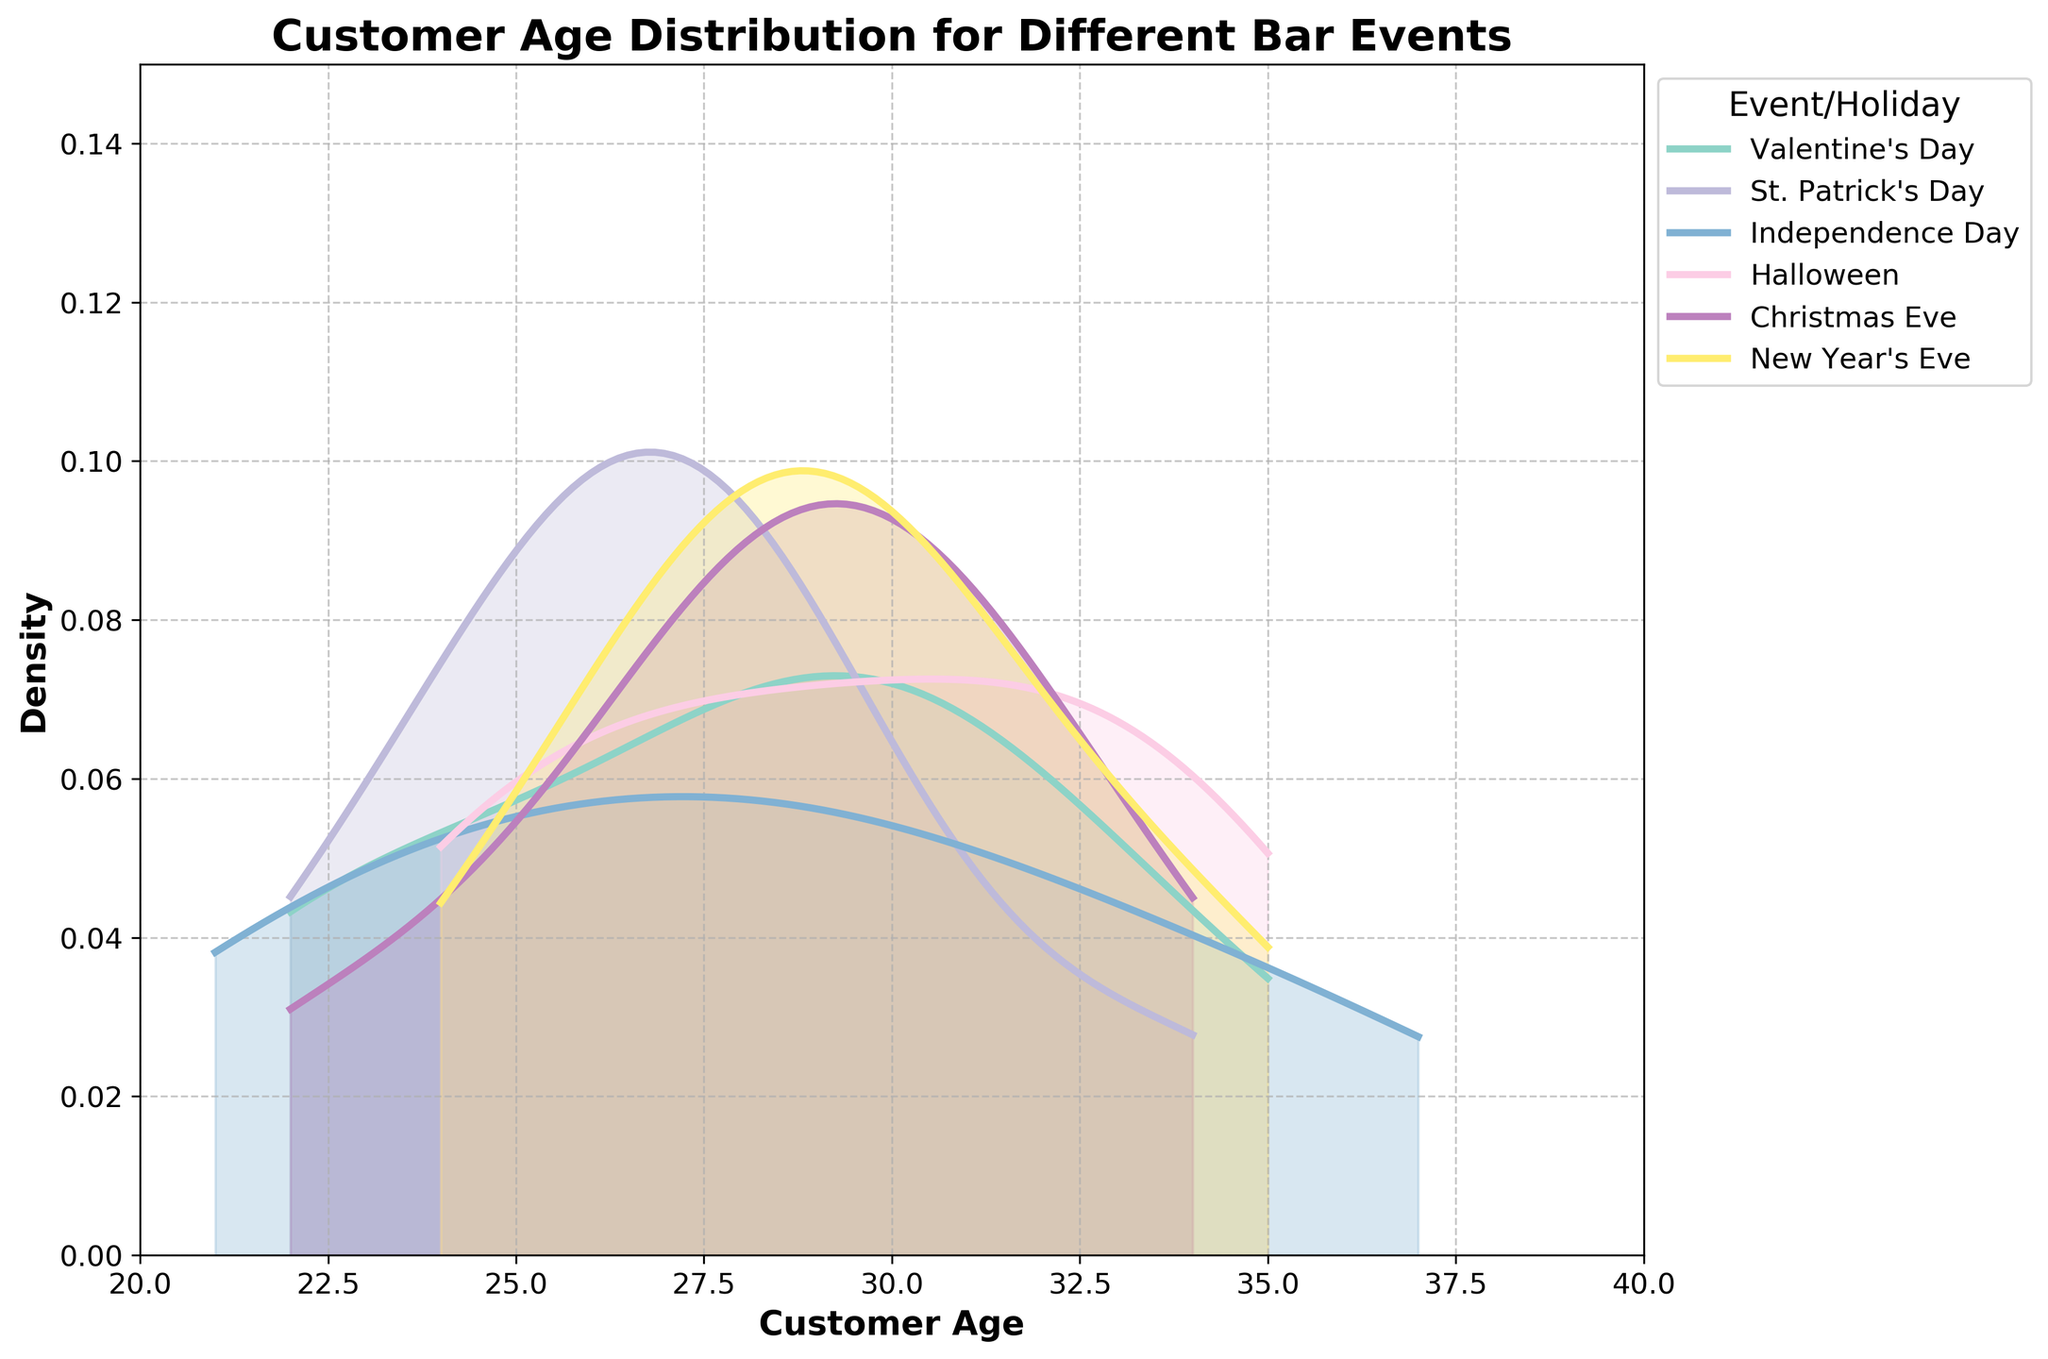What is the title of the figure? The title is typically positioned at the top center of the figure. It summarizes the primary focus of the data plotted. In this figure, it should be easily readable.
Answer: Customer Age Distribution for Different Bar Events Which event has the highest peak height in the density plot? Examine all the density curves and identify the one with the highest peak. The height signifies the density of customer ages.
Answer: New Year's Eve What is the age range shown on the x-axis? The x-axis represents the range of customer ages. By looking at the leftmost and rightmost ticks on this axis, the age range can be identified.
Answer: 20 to 40 Which two events have the most similar customer age distributions? Compare the shapes and peaks of the density curves for each event. Two events with curves that overlap significantly and have similar shapes would be considered as having the most similar distributions.
Answer: Valentine's Day and Halloween What is the age with the highest density for Independence Day? Identify the peak of the density curve specific to Independence Day, which signifies the age with the highest density.
Answer: 26 Between Christmas Eve and Halloween, which event has a wider range of customer ages? Observe and compare the spread of the density curves for both events. The curve that covers a larger span on the x-axis indicates a wider age range.
Answer: Halloween How does the customer age distribution for St. Patrick's Day compare to New Year's Eve? Compare the shapes, peaks, and overall spread of the density curves between these two events. St. Patrick's Day has a more concentrated curve, indicating less age diversity, while New Year's Eve shows a broader spread.
Answer: St. Patrick’s Day is more concentrated; New Year's Eve is more spread out What is the shape of the density curve for Valentine's Day? Look at the curve associated with Valentine's Day and describe whether it has one peak (unimodal), multiple peaks (multimodal), or no distinct peak (uniform).
Answer: Unimodal Which event’s density curve has the highest peak at the age of 30? Examine each event's density curve around the age of 30 and identify which one reaches the highest point.
Answer: New Year's Eve Around what ages do the density curves for all events overlap the most? Identify overlapping regions of the curves. Look for where most of the curves intersect or are close to each other.
Answer: 28 to 30 